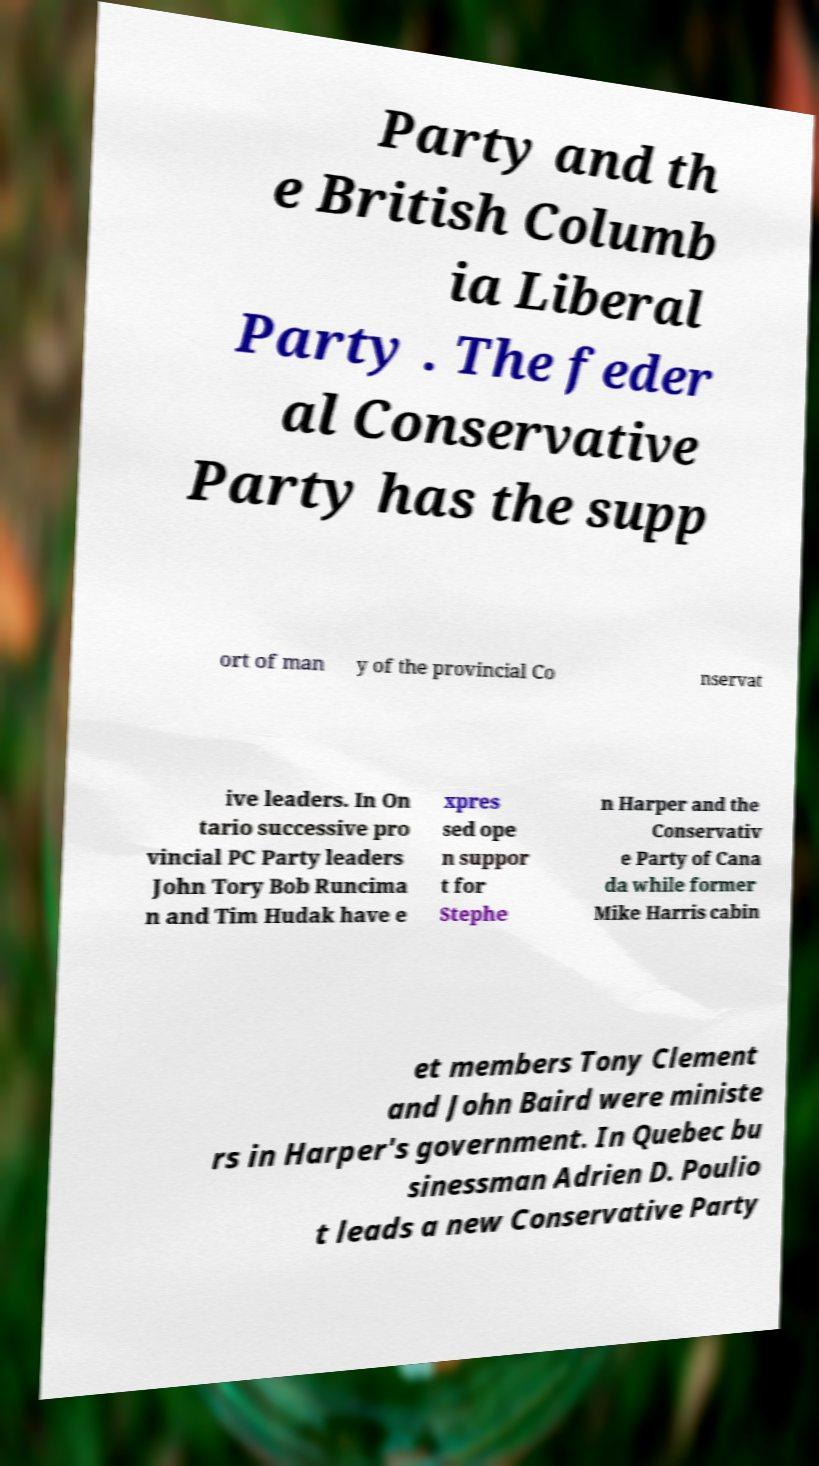Can you read and provide the text displayed in the image?This photo seems to have some interesting text. Can you extract and type it out for me? Party and th e British Columb ia Liberal Party . The feder al Conservative Party has the supp ort of man y of the provincial Co nservat ive leaders. In On tario successive pro vincial PC Party leaders John Tory Bob Runcima n and Tim Hudak have e xpres sed ope n suppor t for Stephe n Harper and the Conservativ e Party of Cana da while former Mike Harris cabin et members Tony Clement and John Baird were ministe rs in Harper's government. In Quebec bu sinessman Adrien D. Poulio t leads a new Conservative Party 